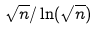<formula> <loc_0><loc_0><loc_500><loc_500>\sqrt { n } / \ln ( \sqrt { n } )</formula> 